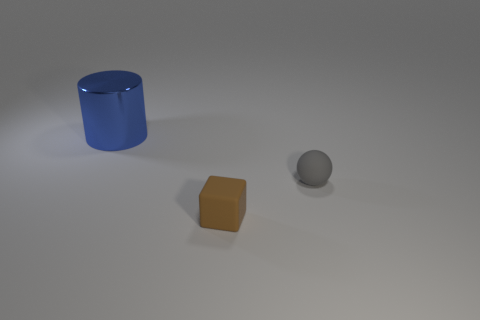Add 1 tiny cyan metal blocks. How many objects exist? 4 Subtract all large things. Subtract all small rubber objects. How many objects are left? 0 Add 2 tiny brown cubes. How many tiny brown cubes are left? 3 Add 1 big purple matte spheres. How many big purple matte spheres exist? 1 Subtract 1 brown cubes. How many objects are left? 2 